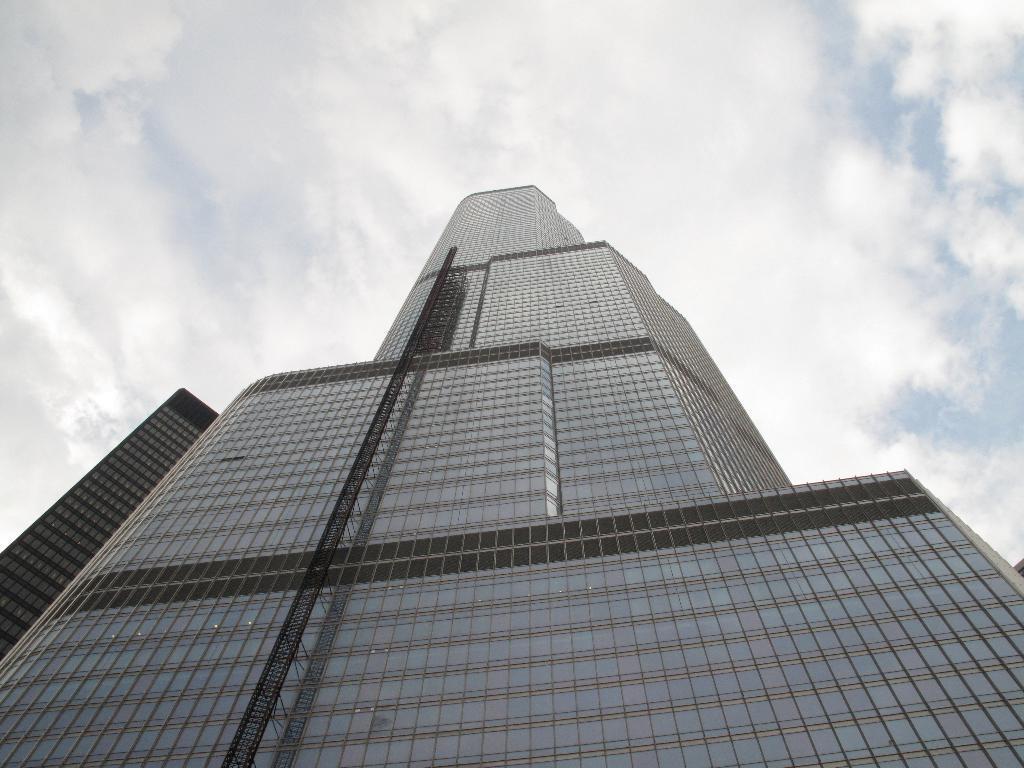In one or two sentences, can you explain what this image depicts? In this image we can see a building. In the background there is sky with clouds. 